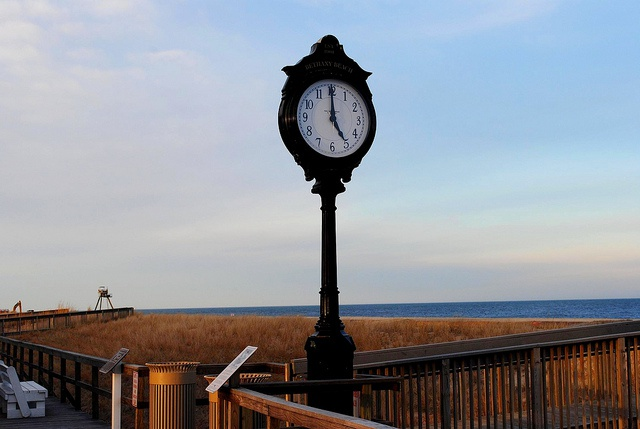Describe the objects in this image and their specific colors. I can see clock in lightgray, gray, and black tones and bench in lightgray, gray, and black tones in this image. 